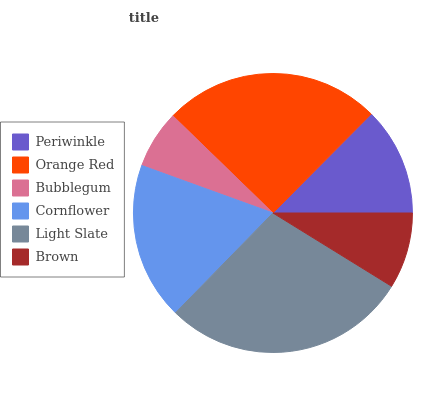Is Bubblegum the minimum?
Answer yes or no. Yes. Is Light Slate the maximum?
Answer yes or no. Yes. Is Orange Red the minimum?
Answer yes or no. No. Is Orange Red the maximum?
Answer yes or no. No. Is Orange Red greater than Periwinkle?
Answer yes or no. Yes. Is Periwinkle less than Orange Red?
Answer yes or no. Yes. Is Periwinkle greater than Orange Red?
Answer yes or no. No. Is Orange Red less than Periwinkle?
Answer yes or no. No. Is Cornflower the high median?
Answer yes or no. Yes. Is Periwinkle the low median?
Answer yes or no. Yes. Is Orange Red the high median?
Answer yes or no. No. Is Cornflower the low median?
Answer yes or no. No. 